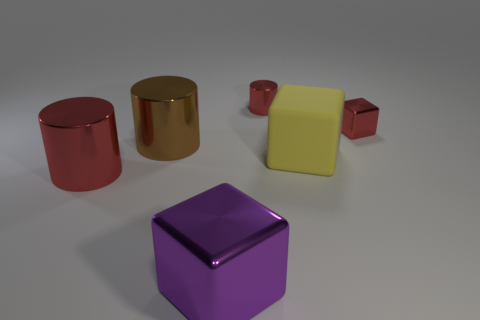What number of other things are there of the same size as the yellow object?
Provide a short and direct response. 3. Are there any shiny cylinders behind the big cube that is on the right side of the small red shiny cylinder that is left of the large yellow matte thing?
Ensure brevity in your answer.  Yes. Are there any other things that are made of the same material as the large yellow object?
Ensure brevity in your answer.  No. What is the shape of the large purple object that is the same material as the red block?
Your answer should be very brief. Cube. Are there fewer red cylinders left of the large red shiny cylinder than big red metal cylinders right of the big yellow rubber cube?
Offer a very short reply. No. How many tiny things are either purple objects or brown cylinders?
Give a very brief answer. 0. Does the red shiny object that is in front of the red metallic cube have the same shape as the small red object that is on the right side of the large rubber block?
Keep it short and to the point. No. How big is the metallic cube that is to the right of the metal cube in front of the yellow object right of the large brown cylinder?
Your response must be concise. Small. What size is the metal object on the right side of the yellow cube?
Provide a short and direct response. Small. What is the material of the red thing in front of the red shiny cube?
Your answer should be compact. Metal. 